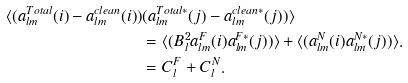<formula> <loc_0><loc_0><loc_500><loc_500>\langle ( a _ { l m } ^ { T o t a l } ( i ) - a _ { l m } ^ { c l e a n } ( i ) ) & ( a _ { l m } ^ { T o t a l * } ( j ) - a _ { l m } ^ { c l e a n * } ( j ) ) \rangle \\ & = \langle ( B _ { l } ^ { 2 } a _ { l m } ^ { F } ( i ) a _ { l m } ^ { F * } ( j ) ) \rangle + \langle ( a _ { l m } ^ { N } ( i ) a _ { l m } ^ { N * } ( j ) ) \rangle . \\ & = C _ { l } ^ { F } + C _ { l } ^ { N } .</formula> 